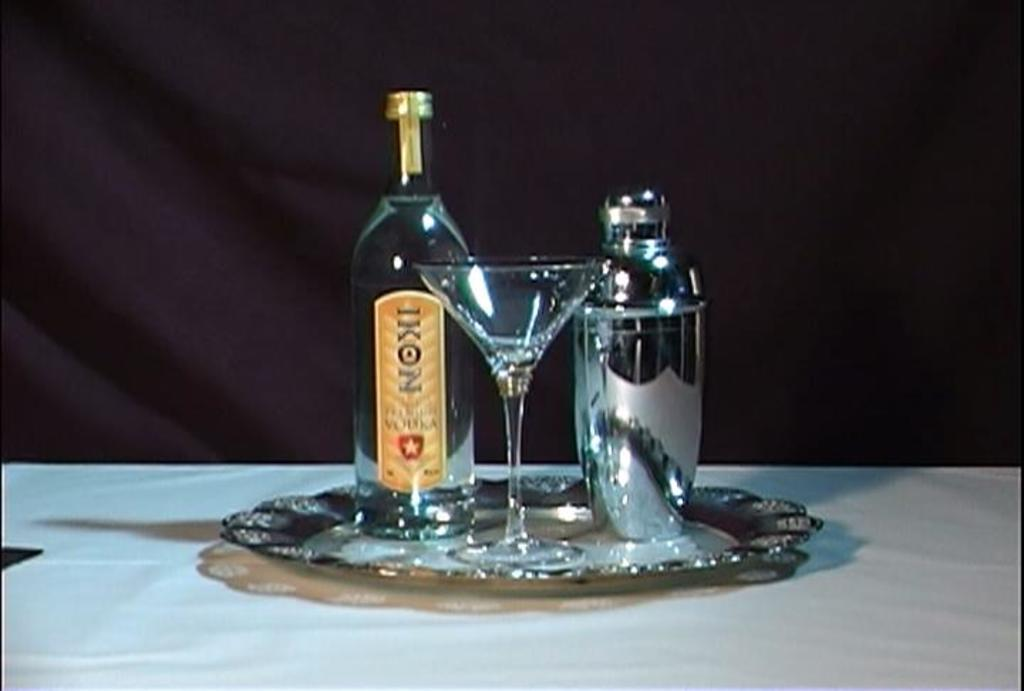What type of alcoholic beverage is featured in the image? There is a vodka bottle in the image. What type of glass is present in the image? There is a glass in the image. What other bar tool can be seen in the image? There is a cocktail shaker in the image. Where are these objects placed in the image? All of these objects are placed on a table. What type of cord is being used to mix the vodka in the image? There is no cord present in the image; it is a still image and does not show any action or process. 